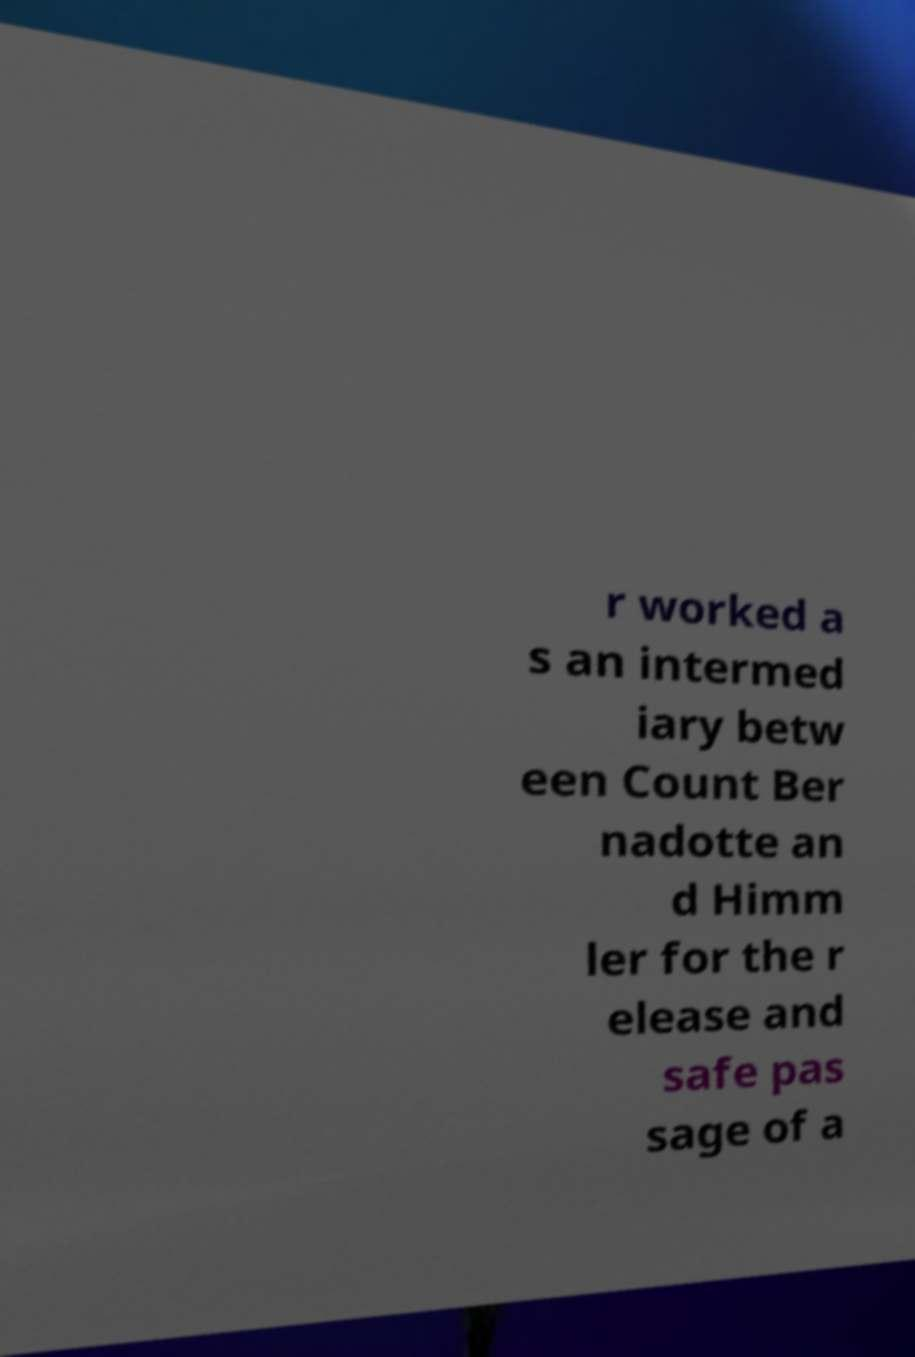Can you read and provide the text displayed in the image?This photo seems to have some interesting text. Can you extract and type it out for me? r worked a s an intermed iary betw een Count Ber nadotte an d Himm ler for the r elease and safe pas sage of a 